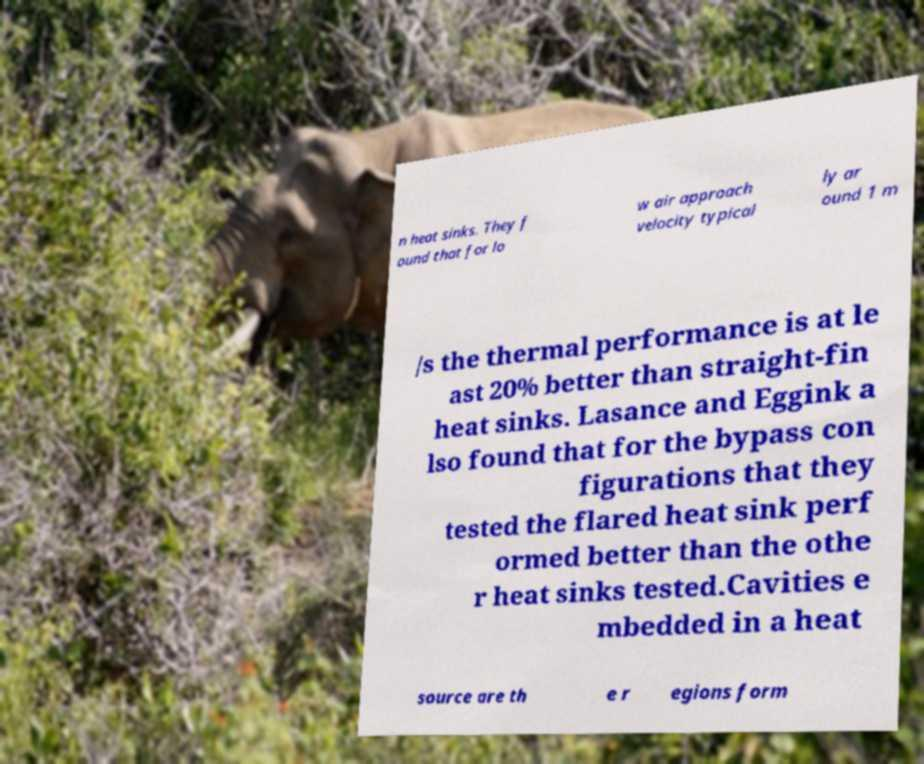Could you extract and type out the text from this image? n heat sinks. They f ound that for lo w air approach velocity typical ly ar ound 1 m /s the thermal performance is at le ast 20% better than straight-fin heat sinks. Lasance and Eggink a lso found that for the bypass con figurations that they tested the flared heat sink perf ormed better than the othe r heat sinks tested.Cavities e mbedded in a heat source are th e r egions form 